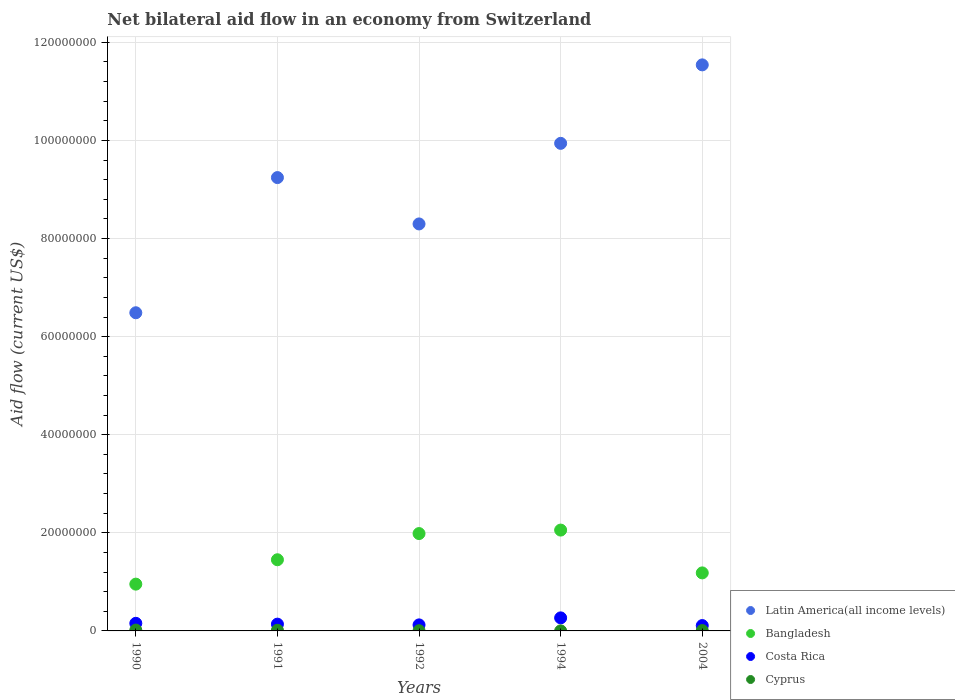Is the number of dotlines equal to the number of legend labels?
Make the answer very short. Yes. What is the net bilateral aid flow in Costa Rica in 1994?
Your answer should be very brief. 2.66e+06. Across all years, what is the maximum net bilateral aid flow in Cyprus?
Provide a short and direct response. 1.70e+05. Across all years, what is the minimum net bilateral aid flow in Bangladesh?
Your answer should be very brief. 9.54e+06. In which year was the net bilateral aid flow in Bangladesh minimum?
Keep it short and to the point. 1990. What is the total net bilateral aid flow in Bangladesh in the graph?
Your answer should be very brief. 7.63e+07. What is the difference between the net bilateral aid flow in Bangladesh in 1991 and the net bilateral aid flow in Cyprus in 2004?
Provide a short and direct response. 1.44e+07. What is the average net bilateral aid flow in Costa Rica per year?
Provide a succinct answer. 1.58e+06. In the year 1991, what is the difference between the net bilateral aid flow in Costa Rica and net bilateral aid flow in Bangladesh?
Give a very brief answer. -1.31e+07. In how many years, is the net bilateral aid flow in Bangladesh greater than 16000000 US$?
Provide a succinct answer. 2. What is the ratio of the net bilateral aid flow in Cyprus in 1992 to that in 2004?
Give a very brief answer. 0.57. Is the difference between the net bilateral aid flow in Costa Rica in 1991 and 1994 greater than the difference between the net bilateral aid flow in Bangladesh in 1991 and 1994?
Provide a succinct answer. Yes. What is the difference between the highest and the lowest net bilateral aid flow in Latin America(all income levels)?
Your answer should be very brief. 5.05e+07. Is the sum of the net bilateral aid flow in Cyprus in 1990 and 2004 greater than the maximum net bilateral aid flow in Costa Rica across all years?
Your answer should be very brief. No. Does the net bilateral aid flow in Costa Rica monotonically increase over the years?
Keep it short and to the point. No. Is the net bilateral aid flow in Bangladesh strictly greater than the net bilateral aid flow in Cyprus over the years?
Make the answer very short. Yes. Is the net bilateral aid flow in Bangladesh strictly less than the net bilateral aid flow in Latin America(all income levels) over the years?
Give a very brief answer. Yes. How many dotlines are there?
Your answer should be compact. 4. What is the difference between two consecutive major ticks on the Y-axis?
Your answer should be very brief. 2.00e+07. Does the graph contain grids?
Your response must be concise. Yes. How are the legend labels stacked?
Ensure brevity in your answer.  Vertical. What is the title of the graph?
Your response must be concise. Net bilateral aid flow in an economy from Switzerland. What is the label or title of the X-axis?
Offer a terse response. Years. What is the label or title of the Y-axis?
Keep it short and to the point. Aid flow (current US$). What is the Aid flow (current US$) in Latin America(all income levels) in 1990?
Your answer should be very brief. 6.49e+07. What is the Aid flow (current US$) of Bangladesh in 1990?
Keep it short and to the point. 9.54e+06. What is the Aid flow (current US$) in Costa Rica in 1990?
Provide a short and direct response. 1.55e+06. What is the Aid flow (current US$) of Cyprus in 1990?
Provide a succinct answer. 1.70e+05. What is the Aid flow (current US$) in Latin America(all income levels) in 1991?
Your answer should be very brief. 9.24e+07. What is the Aid flow (current US$) of Bangladesh in 1991?
Make the answer very short. 1.45e+07. What is the Aid flow (current US$) of Costa Rica in 1991?
Ensure brevity in your answer.  1.38e+06. What is the Aid flow (current US$) in Latin America(all income levels) in 1992?
Your answer should be compact. 8.30e+07. What is the Aid flow (current US$) in Bangladesh in 1992?
Offer a very short reply. 1.98e+07. What is the Aid flow (current US$) of Costa Rica in 1992?
Make the answer very short. 1.23e+06. What is the Aid flow (current US$) of Cyprus in 1992?
Offer a terse response. 4.00e+04. What is the Aid flow (current US$) of Latin America(all income levels) in 1994?
Offer a very short reply. 9.94e+07. What is the Aid flow (current US$) of Bangladesh in 1994?
Give a very brief answer. 2.06e+07. What is the Aid flow (current US$) in Costa Rica in 1994?
Your answer should be compact. 2.66e+06. What is the Aid flow (current US$) of Cyprus in 1994?
Make the answer very short. 10000. What is the Aid flow (current US$) of Latin America(all income levels) in 2004?
Provide a succinct answer. 1.15e+08. What is the Aid flow (current US$) of Bangladesh in 2004?
Provide a succinct answer. 1.18e+07. What is the Aid flow (current US$) in Costa Rica in 2004?
Ensure brevity in your answer.  1.09e+06. Across all years, what is the maximum Aid flow (current US$) in Latin America(all income levels)?
Make the answer very short. 1.15e+08. Across all years, what is the maximum Aid flow (current US$) of Bangladesh?
Ensure brevity in your answer.  2.06e+07. Across all years, what is the maximum Aid flow (current US$) of Costa Rica?
Provide a short and direct response. 2.66e+06. Across all years, what is the maximum Aid flow (current US$) of Cyprus?
Your answer should be compact. 1.70e+05. Across all years, what is the minimum Aid flow (current US$) in Latin America(all income levels)?
Offer a terse response. 6.49e+07. Across all years, what is the minimum Aid flow (current US$) in Bangladesh?
Your answer should be compact. 9.54e+06. Across all years, what is the minimum Aid flow (current US$) in Costa Rica?
Your response must be concise. 1.09e+06. Across all years, what is the minimum Aid flow (current US$) in Cyprus?
Keep it short and to the point. 10000. What is the total Aid flow (current US$) in Latin America(all income levels) in the graph?
Your answer should be very brief. 4.55e+08. What is the total Aid flow (current US$) in Bangladesh in the graph?
Offer a terse response. 7.63e+07. What is the total Aid flow (current US$) of Costa Rica in the graph?
Make the answer very short. 7.91e+06. What is the difference between the Aid flow (current US$) in Latin America(all income levels) in 1990 and that in 1991?
Your response must be concise. -2.76e+07. What is the difference between the Aid flow (current US$) in Bangladesh in 1990 and that in 1991?
Your answer should be compact. -4.97e+06. What is the difference between the Aid flow (current US$) in Latin America(all income levels) in 1990 and that in 1992?
Make the answer very short. -1.81e+07. What is the difference between the Aid flow (current US$) of Bangladesh in 1990 and that in 1992?
Your answer should be very brief. -1.03e+07. What is the difference between the Aid flow (current US$) in Latin America(all income levels) in 1990 and that in 1994?
Keep it short and to the point. -3.45e+07. What is the difference between the Aid flow (current US$) of Bangladesh in 1990 and that in 1994?
Ensure brevity in your answer.  -1.10e+07. What is the difference between the Aid flow (current US$) in Costa Rica in 1990 and that in 1994?
Your answer should be very brief. -1.11e+06. What is the difference between the Aid flow (current US$) in Latin America(all income levels) in 1990 and that in 2004?
Make the answer very short. -5.05e+07. What is the difference between the Aid flow (current US$) in Bangladesh in 1990 and that in 2004?
Make the answer very short. -2.29e+06. What is the difference between the Aid flow (current US$) of Costa Rica in 1990 and that in 2004?
Make the answer very short. 4.60e+05. What is the difference between the Aid flow (current US$) in Cyprus in 1990 and that in 2004?
Your answer should be compact. 1.00e+05. What is the difference between the Aid flow (current US$) in Latin America(all income levels) in 1991 and that in 1992?
Your answer should be compact. 9.45e+06. What is the difference between the Aid flow (current US$) of Bangladesh in 1991 and that in 1992?
Give a very brief answer. -5.34e+06. What is the difference between the Aid flow (current US$) of Costa Rica in 1991 and that in 1992?
Provide a succinct answer. 1.50e+05. What is the difference between the Aid flow (current US$) in Latin America(all income levels) in 1991 and that in 1994?
Offer a very short reply. -6.98e+06. What is the difference between the Aid flow (current US$) of Bangladesh in 1991 and that in 1994?
Your answer should be compact. -6.05e+06. What is the difference between the Aid flow (current US$) of Costa Rica in 1991 and that in 1994?
Offer a terse response. -1.28e+06. What is the difference between the Aid flow (current US$) in Latin America(all income levels) in 1991 and that in 2004?
Give a very brief answer. -2.30e+07. What is the difference between the Aid flow (current US$) in Bangladesh in 1991 and that in 2004?
Your answer should be very brief. 2.68e+06. What is the difference between the Aid flow (current US$) in Cyprus in 1991 and that in 2004?
Give a very brief answer. 6.00e+04. What is the difference between the Aid flow (current US$) of Latin America(all income levels) in 1992 and that in 1994?
Provide a short and direct response. -1.64e+07. What is the difference between the Aid flow (current US$) in Bangladesh in 1992 and that in 1994?
Your answer should be compact. -7.10e+05. What is the difference between the Aid flow (current US$) of Costa Rica in 1992 and that in 1994?
Your response must be concise. -1.43e+06. What is the difference between the Aid flow (current US$) of Cyprus in 1992 and that in 1994?
Ensure brevity in your answer.  3.00e+04. What is the difference between the Aid flow (current US$) of Latin America(all income levels) in 1992 and that in 2004?
Your answer should be very brief. -3.24e+07. What is the difference between the Aid flow (current US$) of Bangladesh in 1992 and that in 2004?
Provide a short and direct response. 8.02e+06. What is the difference between the Aid flow (current US$) in Cyprus in 1992 and that in 2004?
Your response must be concise. -3.00e+04. What is the difference between the Aid flow (current US$) in Latin America(all income levels) in 1994 and that in 2004?
Keep it short and to the point. -1.60e+07. What is the difference between the Aid flow (current US$) in Bangladesh in 1994 and that in 2004?
Offer a very short reply. 8.73e+06. What is the difference between the Aid flow (current US$) in Costa Rica in 1994 and that in 2004?
Give a very brief answer. 1.57e+06. What is the difference between the Aid flow (current US$) of Cyprus in 1994 and that in 2004?
Give a very brief answer. -6.00e+04. What is the difference between the Aid flow (current US$) of Latin America(all income levels) in 1990 and the Aid flow (current US$) of Bangladesh in 1991?
Offer a very short reply. 5.04e+07. What is the difference between the Aid flow (current US$) in Latin America(all income levels) in 1990 and the Aid flow (current US$) in Costa Rica in 1991?
Provide a short and direct response. 6.35e+07. What is the difference between the Aid flow (current US$) of Latin America(all income levels) in 1990 and the Aid flow (current US$) of Cyprus in 1991?
Ensure brevity in your answer.  6.47e+07. What is the difference between the Aid flow (current US$) in Bangladesh in 1990 and the Aid flow (current US$) in Costa Rica in 1991?
Provide a short and direct response. 8.16e+06. What is the difference between the Aid flow (current US$) of Bangladesh in 1990 and the Aid flow (current US$) of Cyprus in 1991?
Give a very brief answer. 9.41e+06. What is the difference between the Aid flow (current US$) in Costa Rica in 1990 and the Aid flow (current US$) in Cyprus in 1991?
Keep it short and to the point. 1.42e+06. What is the difference between the Aid flow (current US$) of Latin America(all income levels) in 1990 and the Aid flow (current US$) of Bangladesh in 1992?
Offer a very short reply. 4.50e+07. What is the difference between the Aid flow (current US$) in Latin America(all income levels) in 1990 and the Aid flow (current US$) in Costa Rica in 1992?
Provide a succinct answer. 6.36e+07. What is the difference between the Aid flow (current US$) in Latin America(all income levels) in 1990 and the Aid flow (current US$) in Cyprus in 1992?
Offer a terse response. 6.48e+07. What is the difference between the Aid flow (current US$) in Bangladesh in 1990 and the Aid flow (current US$) in Costa Rica in 1992?
Make the answer very short. 8.31e+06. What is the difference between the Aid flow (current US$) of Bangladesh in 1990 and the Aid flow (current US$) of Cyprus in 1992?
Offer a terse response. 9.50e+06. What is the difference between the Aid flow (current US$) of Costa Rica in 1990 and the Aid flow (current US$) of Cyprus in 1992?
Keep it short and to the point. 1.51e+06. What is the difference between the Aid flow (current US$) of Latin America(all income levels) in 1990 and the Aid flow (current US$) of Bangladesh in 1994?
Your response must be concise. 4.43e+07. What is the difference between the Aid flow (current US$) of Latin America(all income levels) in 1990 and the Aid flow (current US$) of Costa Rica in 1994?
Give a very brief answer. 6.22e+07. What is the difference between the Aid flow (current US$) of Latin America(all income levels) in 1990 and the Aid flow (current US$) of Cyprus in 1994?
Keep it short and to the point. 6.49e+07. What is the difference between the Aid flow (current US$) in Bangladesh in 1990 and the Aid flow (current US$) in Costa Rica in 1994?
Ensure brevity in your answer.  6.88e+06. What is the difference between the Aid flow (current US$) in Bangladesh in 1990 and the Aid flow (current US$) in Cyprus in 1994?
Make the answer very short. 9.53e+06. What is the difference between the Aid flow (current US$) of Costa Rica in 1990 and the Aid flow (current US$) of Cyprus in 1994?
Give a very brief answer. 1.54e+06. What is the difference between the Aid flow (current US$) in Latin America(all income levels) in 1990 and the Aid flow (current US$) in Bangladesh in 2004?
Provide a succinct answer. 5.30e+07. What is the difference between the Aid flow (current US$) in Latin America(all income levels) in 1990 and the Aid flow (current US$) in Costa Rica in 2004?
Offer a very short reply. 6.38e+07. What is the difference between the Aid flow (current US$) of Latin America(all income levels) in 1990 and the Aid flow (current US$) of Cyprus in 2004?
Give a very brief answer. 6.48e+07. What is the difference between the Aid flow (current US$) of Bangladesh in 1990 and the Aid flow (current US$) of Costa Rica in 2004?
Your answer should be compact. 8.45e+06. What is the difference between the Aid flow (current US$) in Bangladesh in 1990 and the Aid flow (current US$) in Cyprus in 2004?
Offer a terse response. 9.47e+06. What is the difference between the Aid flow (current US$) of Costa Rica in 1990 and the Aid flow (current US$) of Cyprus in 2004?
Keep it short and to the point. 1.48e+06. What is the difference between the Aid flow (current US$) in Latin America(all income levels) in 1991 and the Aid flow (current US$) in Bangladesh in 1992?
Your answer should be very brief. 7.26e+07. What is the difference between the Aid flow (current US$) of Latin America(all income levels) in 1991 and the Aid flow (current US$) of Costa Rica in 1992?
Your response must be concise. 9.12e+07. What is the difference between the Aid flow (current US$) of Latin America(all income levels) in 1991 and the Aid flow (current US$) of Cyprus in 1992?
Make the answer very short. 9.24e+07. What is the difference between the Aid flow (current US$) of Bangladesh in 1991 and the Aid flow (current US$) of Costa Rica in 1992?
Provide a short and direct response. 1.33e+07. What is the difference between the Aid flow (current US$) of Bangladesh in 1991 and the Aid flow (current US$) of Cyprus in 1992?
Offer a terse response. 1.45e+07. What is the difference between the Aid flow (current US$) of Costa Rica in 1991 and the Aid flow (current US$) of Cyprus in 1992?
Provide a short and direct response. 1.34e+06. What is the difference between the Aid flow (current US$) of Latin America(all income levels) in 1991 and the Aid flow (current US$) of Bangladesh in 1994?
Offer a terse response. 7.19e+07. What is the difference between the Aid flow (current US$) in Latin America(all income levels) in 1991 and the Aid flow (current US$) in Costa Rica in 1994?
Ensure brevity in your answer.  8.98e+07. What is the difference between the Aid flow (current US$) in Latin America(all income levels) in 1991 and the Aid flow (current US$) in Cyprus in 1994?
Keep it short and to the point. 9.24e+07. What is the difference between the Aid flow (current US$) of Bangladesh in 1991 and the Aid flow (current US$) of Costa Rica in 1994?
Your answer should be very brief. 1.18e+07. What is the difference between the Aid flow (current US$) in Bangladesh in 1991 and the Aid flow (current US$) in Cyprus in 1994?
Your response must be concise. 1.45e+07. What is the difference between the Aid flow (current US$) in Costa Rica in 1991 and the Aid flow (current US$) in Cyprus in 1994?
Provide a succinct answer. 1.37e+06. What is the difference between the Aid flow (current US$) in Latin America(all income levels) in 1991 and the Aid flow (current US$) in Bangladesh in 2004?
Provide a succinct answer. 8.06e+07. What is the difference between the Aid flow (current US$) of Latin America(all income levels) in 1991 and the Aid flow (current US$) of Costa Rica in 2004?
Your response must be concise. 9.13e+07. What is the difference between the Aid flow (current US$) in Latin America(all income levels) in 1991 and the Aid flow (current US$) in Cyprus in 2004?
Offer a very short reply. 9.24e+07. What is the difference between the Aid flow (current US$) of Bangladesh in 1991 and the Aid flow (current US$) of Costa Rica in 2004?
Keep it short and to the point. 1.34e+07. What is the difference between the Aid flow (current US$) of Bangladesh in 1991 and the Aid flow (current US$) of Cyprus in 2004?
Your answer should be very brief. 1.44e+07. What is the difference between the Aid flow (current US$) in Costa Rica in 1991 and the Aid flow (current US$) in Cyprus in 2004?
Provide a succinct answer. 1.31e+06. What is the difference between the Aid flow (current US$) of Latin America(all income levels) in 1992 and the Aid flow (current US$) of Bangladesh in 1994?
Offer a terse response. 6.24e+07. What is the difference between the Aid flow (current US$) in Latin America(all income levels) in 1992 and the Aid flow (current US$) in Costa Rica in 1994?
Ensure brevity in your answer.  8.03e+07. What is the difference between the Aid flow (current US$) of Latin America(all income levels) in 1992 and the Aid flow (current US$) of Cyprus in 1994?
Give a very brief answer. 8.30e+07. What is the difference between the Aid flow (current US$) in Bangladesh in 1992 and the Aid flow (current US$) in Costa Rica in 1994?
Your response must be concise. 1.72e+07. What is the difference between the Aid flow (current US$) of Bangladesh in 1992 and the Aid flow (current US$) of Cyprus in 1994?
Ensure brevity in your answer.  1.98e+07. What is the difference between the Aid flow (current US$) of Costa Rica in 1992 and the Aid flow (current US$) of Cyprus in 1994?
Ensure brevity in your answer.  1.22e+06. What is the difference between the Aid flow (current US$) in Latin America(all income levels) in 1992 and the Aid flow (current US$) in Bangladesh in 2004?
Make the answer very short. 7.12e+07. What is the difference between the Aid flow (current US$) in Latin America(all income levels) in 1992 and the Aid flow (current US$) in Costa Rica in 2004?
Provide a short and direct response. 8.19e+07. What is the difference between the Aid flow (current US$) in Latin America(all income levels) in 1992 and the Aid flow (current US$) in Cyprus in 2004?
Keep it short and to the point. 8.29e+07. What is the difference between the Aid flow (current US$) in Bangladesh in 1992 and the Aid flow (current US$) in Costa Rica in 2004?
Your answer should be very brief. 1.88e+07. What is the difference between the Aid flow (current US$) of Bangladesh in 1992 and the Aid flow (current US$) of Cyprus in 2004?
Your response must be concise. 1.98e+07. What is the difference between the Aid flow (current US$) of Costa Rica in 1992 and the Aid flow (current US$) of Cyprus in 2004?
Keep it short and to the point. 1.16e+06. What is the difference between the Aid flow (current US$) in Latin America(all income levels) in 1994 and the Aid flow (current US$) in Bangladesh in 2004?
Your answer should be very brief. 8.76e+07. What is the difference between the Aid flow (current US$) of Latin America(all income levels) in 1994 and the Aid flow (current US$) of Costa Rica in 2004?
Your response must be concise. 9.83e+07. What is the difference between the Aid flow (current US$) of Latin America(all income levels) in 1994 and the Aid flow (current US$) of Cyprus in 2004?
Provide a short and direct response. 9.93e+07. What is the difference between the Aid flow (current US$) of Bangladesh in 1994 and the Aid flow (current US$) of Costa Rica in 2004?
Your response must be concise. 1.95e+07. What is the difference between the Aid flow (current US$) of Bangladesh in 1994 and the Aid flow (current US$) of Cyprus in 2004?
Your answer should be compact. 2.05e+07. What is the difference between the Aid flow (current US$) in Costa Rica in 1994 and the Aid flow (current US$) in Cyprus in 2004?
Give a very brief answer. 2.59e+06. What is the average Aid flow (current US$) of Latin America(all income levels) per year?
Provide a short and direct response. 9.10e+07. What is the average Aid flow (current US$) of Bangladesh per year?
Offer a terse response. 1.53e+07. What is the average Aid flow (current US$) in Costa Rica per year?
Provide a short and direct response. 1.58e+06. What is the average Aid flow (current US$) of Cyprus per year?
Your answer should be very brief. 8.40e+04. In the year 1990, what is the difference between the Aid flow (current US$) in Latin America(all income levels) and Aid flow (current US$) in Bangladesh?
Keep it short and to the point. 5.53e+07. In the year 1990, what is the difference between the Aid flow (current US$) of Latin America(all income levels) and Aid flow (current US$) of Costa Rica?
Offer a very short reply. 6.33e+07. In the year 1990, what is the difference between the Aid flow (current US$) in Latin America(all income levels) and Aid flow (current US$) in Cyprus?
Give a very brief answer. 6.47e+07. In the year 1990, what is the difference between the Aid flow (current US$) of Bangladesh and Aid flow (current US$) of Costa Rica?
Make the answer very short. 7.99e+06. In the year 1990, what is the difference between the Aid flow (current US$) in Bangladesh and Aid flow (current US$) in Cyprus?
Offer a very short reply. 9.37e+06. In the year 1990, what is the difference between the Aid flow (current US$) of Costa Rica and Aid flow (current US$) of Cyprus?
Offer a very short reply. 1.38e+06. In the year 1991, what is the difference between the Aid flow (current US$) in Latin America(all income levels) and Aid flow (current US$) in Bangladesh?
Make the answer very short. 7.79e+07. In the year 1991, what is the difference between the Aid flow (current US$) in Latin America(all income levels) and Aid flow (current US$) in Costa Rica?
Your answer should be very brief. 9.10e+07. In the year 1991, what is the difference between the Aid flow (current US$) of Latin America(all income levels) and Aid flow (current US$) of Cyprus?
Your answer should be compact. 9.23e+07. In the year 1991, what is the difference between the Aid flow (current US$) in Bangladesh and Aid flow (current US$) in Costa Rica?
Offer a terse response. 1.31e+07. In the year 1991, what is the difference between the Aid flow (current US$) of Bangladesh and Aid flow (current US$) of Cyprus?
Offer a very short reply. 1.44e+07. In the year 1991, what is the difference between the Aid flow (current US$) in Costa Rica and Aid flow (current US$) in Cyprus?
Your answer should be compact. 1.25e+06. In the year 1992, what is the difference between the Aid flow (current US$) of Latin America(all income levels) and Aid flow (current US$) of Bangladesh?
Your answer should be very brief. 6.31e+07. In the year 1992, what is the difference between the Aid flow (current US$) in Latin America(all income levels) and Aid flow (current US$) in Costa Rica?
Provide a succinct answer. 8.18e+07. In the year 1992, what is the difference between the Aid flow (current US$) of Latin America(all income levels) and Aid flow (current US$) of Cyprus?
Keep it short and to the point. 8.29e+07. In the year 1992, what is the difference between the Aid flow (current US$) of Bangladesh and Aid flow (current US$) of Costa Rica?
Give a very brief answer. 1.86e+07. In the year 1992, what is the difference between the Aid flow (current US$) in Bangladesh and Aid flow (current US$) in Cyprus?
Make the answer very short. 1.98e+07. In the year 1992, what is the difference between the Aid flow (current US$) of Costa Rica and Aid flow (current US$) of Cyprus?
Your answer should be very brief. 1.19e+06. In the year 1994, what is the difference between the Aid flow (current US$) of Latin America(all income levels) and Aid flow (current US$) of Bangladesh?
Make the answer very short. 7.88e+07. In the year 1994, what is the difference between the Aid flow (current US$) in Latin America(all income levels) and Aid flow (current US$) in Costa Rica?
Provide a short and direct response. 9.68e+07. In the year 1994, what is the difference between the Aid flow (current US$) in Latin America(all income levels) and Aid flow (current US$) in Cyprus?
Offer a terse response. 9.94e+07. In the year 1994, what is the difference between the Aid flow (current US$) in Bangladesh and Aid flow (current US$) in Costa Rica?
Provide a succinct answer. 1.79e+07. In the year 1994, what is the difference between the Aid flow (current US$) of Bangladesh and Aid flow (current US$) of Cyprus?
Your answer should be compact. 2.06e+07. In the year 1994, what is the difference between the Aid flow (current US$) of Costa Rica and Aid flow (current US$) of Cyprus?
Ensure brevity in your answer.  2.65e+06. In the year 2004, what is the difference between the Aid flow (current US$) of Latin America(all income levels) and Aid flow (current US$) of Bangladesh?
Offer a terse response. 1.04e+08. In the year 2004, what is the difference between the Aid flow (current US$) in Latin America(all income levels) and Aid flow (current US$) in Costa Rica?
Your answer should be very brief. 1.14e+08. In the year 2004, what is the difference between the Aid flow (current US$) of Latin America(all income levels) and Aid flow (current US$) of Cyprus?
Your response must be concise. 1.15e+08. In the year 2004, what is the difference between the Aid flow (current US$) in Bangladesh and Aid flow (current US$) in Costa Rica?
Keep it short and to the point. 1.07e+07. In the year 2004, what is the difference between the Aid flow (current US$) in Bangladesh and Aid flow (current US$) in Cyprus?
Offer a terse response. 1.18e+07. In the year 2004, what is the difference between the Aid flow (current US$) in Costa Rica and Aid flow (current US$) in Cyprus?
Offer a terse response. 1.02e+06. What is the ratio of the Aid flow (current US$) in Latin America(all income levels) in 1990 to that in 1991?
Offer a very short reply. 0.7. What is the ratio of the Aid flow (current US$) in Bangladesh in 1990 to that in 1991?
Your response must be concise. 0.66. What is the ratio of the Aid flow (current US$) of Costa Rica in 1990 to that in 1991?
Provide a short and direct response. 1.12. What is the ratio of the Aid flow (current US$) in Cyprus in 1990 to that in 1991?
Ensure brevity in your answer.  1.31. What is the ratio of the Aid flow (current US$) of Latin America(all income levels) in 1990 to that in 1992?
Your answer should be very brief. 0.78. What is the ratio of the Aid flow (current US$) in Bangladesh in 1990 to that in 1992?
Your answer should be compact. 0.48. What is the ratio of the Aid flow (current US$) of Costa Rica in 1990 to that in 1992?
Provide a succinct answer. 1.26. What is the ratio of the Aid flow (current US$) in Cyprus in 1990 to that in 1992?
Keep it short and to the point. 4.25. What is the ratio of the Aid flow (current US$) of Latin America(all income levels) in 1990 to that in 1994?
Your response must be concise. 0.65. What is the ratio of the Aid flow (current US$) of Bangladesh in 1990 to that in 1994?
Your response must be concise. 0.46. What is the ratio of the Aid flow (current US$) in Costa Rica in 1990 to that in 1994?
Your answer should be very brief. 0.58. What is the ratio of the Aid flow (current US$) in Cyprus in 1990 to that in 1994?
Provide a short and direct response. 17. What is the ratio of the Aid flow (current US$) in Latin America(all income levels) in 1990 to that in 2004?
Your answer should be compact. 0.56. What is the ratio of the Aid flow (current US$) of Bangladesh in 1990 to that in 2004?
Ensure brevity in your answer.  0.81. What is the ratio of the Aid flow (current US$) of Costa Rica in 1990 to that in 2004?
Make the answer very short. 1.42. What is the ratio of the Aid flow (current US$) of Cyprus in 1990 to that in 2004?
Provide a succinct answer. 2.43. What is the ratio of the Aid flow (current US$) in Latin America(all income levels) in 1991 to that in 1992?
Ensure brevity in your answer.  1.11. What is the ratio of the Aid flow (current US$) of Bangladesh in 1991 to that in 1992?
Your answer should be very brief. 0.73. What is the ratio of the Aid flow (current US$) in Costa Rica in 1991 to that in 1992?
Offer a terse response. 1.12. What is the ratio of the Aid flow (current US$) in Cyprus in 1991 to that in 1992?
Make the answer very short. 3.25. What is the ratio of the Aid flow (current US$) of Latin America(all income levels) in 1991 to that in 1994?
Offer a very short reply. 0.93. What is the ratio of the Aid flow (current US$) in Bangladesh in 1991 to that in 1994?
Provide a short and direct response. 0.71. What is the ratio of the Aid flow (current US$) in Costa Rica in 1991 to that in 1994?
Keep it short and to the point. 0.52. What is the ratio of the Aid flow (current US$) in Cyprus in 1991 to that in 1994?
Keep it short and to the point. 13. What is the ratio of the Aid flow (current US$) of Latin America(all income levels) in 1991 to that in 2004?
Provide a succinct answer. 0.8. What is the ratio of the Aid flow (current US$) in Bangladesh in 1991 to that in 2004?
Provide a short and direct response. 1.23. What is the ratio of the Aid flow (current US$) in Costa Rica in 1991 to that in 2004?
Offer a very short reply. 1.27. What is the ratio of the Aid flow (current US$) of Cyprus in 1991 to that in 2004?
Your answer should be compact. 1.86. What is the ratio of the Aid flow (current US$) of Latin America(all income levels) in 1992 to that in 1994?
Make the answer very short. 0.83. What is the ratio of the Aid flow (current US$) in Bangladesh in 1992 to that in 1994?
Your answer should be very brief. 0.97. What is the ratio of the Aid flow (current US$) in Costa Rica in 1992 to that in 1994?
Give a very brief answer. 0.46. What is the ratio of the Aid flow (current US$) in Cyprus in 1992 to that in 1994?
Provide a succinct answer. 4. What is the ratio of the Aid flow (current US$) of Latin America(all income levels) in 1992 to that in 2004?
Provide a short and direct response. 0.72. What is the ratio of the Aid flow (current US$) of Bangladesh in 1992 to that in 2004?
Provide a short and direct response. 1.68. What is the ratio of the Aid flow (current US$) of Costa Rica in 1992 to that in 2004?
Provide a short and direct response. 1.13. What is the ratio of the Aid flow (current US$) in Cyprus in 1992 to that in 2004?
Offer a terse response. 0.57. What is the ratio of the Aid flow (current US$) in Latin America(all income levels) in 1994 to that in 2004?
Make the answer very short. 0.86. What is the ratio of the Aid flow (current US$) in Bangladesh in 1994 to that in 2004?
Provide a short and direct response. 1.74. What is the ratio of the Aid flow (current US$) of Costa Rica in 1994 to that in 2004?
Give a very brief answer. 2.44. What is the ratio of the Aid flow (current US$) of Cyprus in 1994 to that in 2004?
Provide a succinct answer. 0.14. What is the difference between the highest and the second highest Aid flow (current US$) of Latin America(all income levels)?
Make the answer very short. 1.60e+07. What is the difference between the highest and the second highest Aid flow (current US$) of Bangladesh?
Your answer should be very brief. 7.10e+05. What is the difference between the highest and the second highest Aid flow (current US$) of Costa Rica?
Offer a terse response. 1.11e+06. What is the difference between the highest and the lowest Aid flow (current US$) of Latin America(all income levels)?
Your response must be concise. 5.05e+07. What is the difference between the highest and the lowest Aid flow (current US$) of Bangladesh?
Offer a very short reply. 1.10e+07. What is the difference between the highest and the lowest Aid flow (current US$) in Costa Rica?
Ensure brevity in your answer.  1.57e+06. What is the difference between the highest and the lowest Aid flow (current US$) in Cyprus?
Offer a terse response. 1.60e+05. 